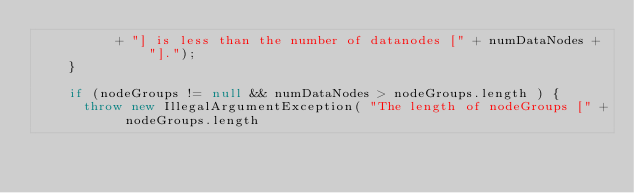Convert code to text. <code><loc_0><loc_0><loc_500><loc_500><_Java_>          + "] is less than the number of datanodes [" + numDataNodes + "].");
    }

    if (nodeGroups != null && numDataNodes > nodeGroups.length ) {
      throw new IllegalArgumentException( "The length of nodeGroups [" + nodeGroups.length</code> 